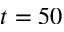Convert formula to latex. <formula><loc_0><loc_0><loc_500><loc_500>t = 5 0</formula> 